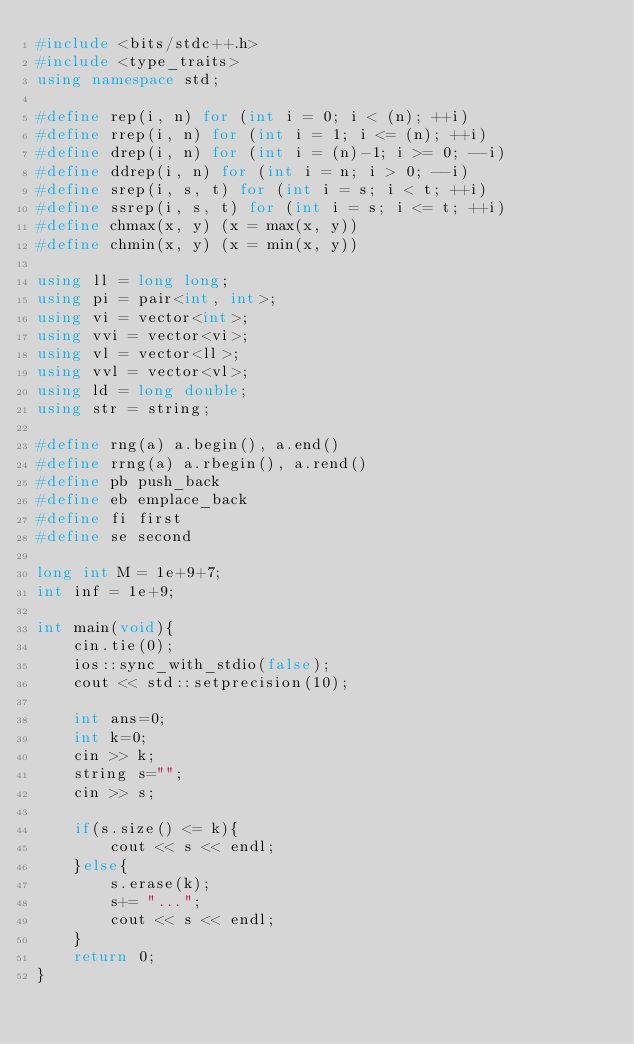Convert code to text. <code><loc_0><loc_0><loc_500><loc_500><_C++_>#include <bits/stdc++.h>
#include <type_traits>
using namespace std;

#define rep(i, n) for (int i = 0; i < (n); ++i)
#define rrep(i, n) for (int i = 1; i <= (n); ++i)
#define drep(i, n) for (int i = (n)-1; i >= 0; --i)
#define ddrep(i, n) for (int i = n; i > 0; --i)
#define srep(i, s, t) for (int i = s; i < t; ++i)
#define ssrep(i, s, t) for (int i = s; i <= t; ++i)
#define chmax(x, y) (x = max(x, y))
#define chmin(x, y) (x = min(x, y))

using ll = long long;
using pi = pair<int, int>;
using vi = vector<int>;
using vvi = vector<vi>;
using vl = vector<ll>;
using vvl = vector<vl>;
using ld = long double;
using str = string;

#define rng(a) a.begin(), a.end()
#define rrng(a) a.rbegin(), a.rend()
#define pb push_back
#define eb emplace_back
#define fi first
#define se second

long int M = 1e+9+7;
int inf = 1e+9;

int main(void){
    cin.tie(0);
    ios::sync_with_stdio(false);
    cout << std::setprecision(10);

    int ans=0;
    int k=0;
    cin >> k;
    string s="";
    cin >> s;
    
    if(s.size() <= k){
        cout << s << endl;
    }else{
        s.erase(k);
        s+= "...";
        cout << s << endl;
    }
    return 0;
}</code> 